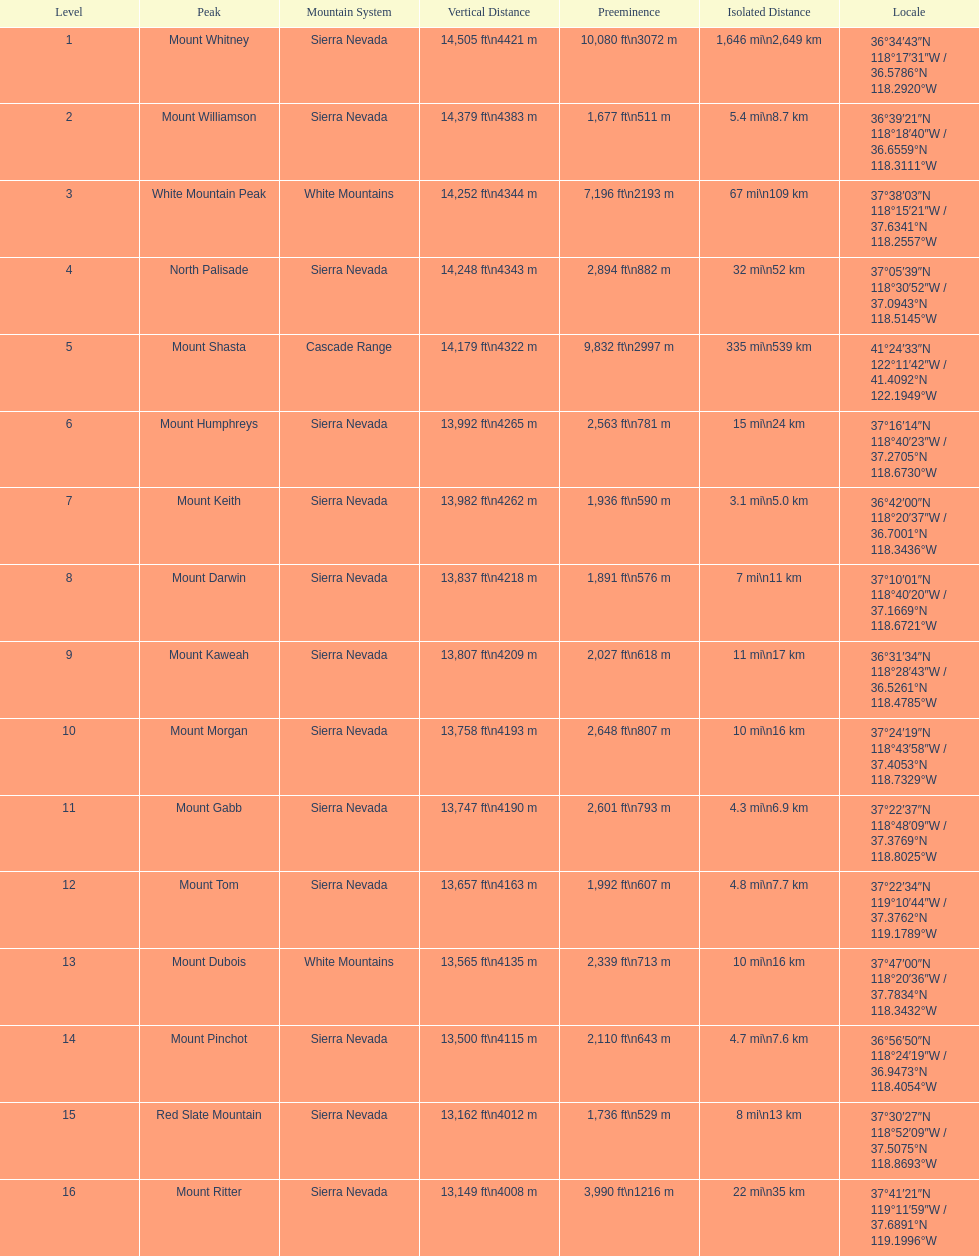How much taller is the mountain peak of mount williamson than that of mount keith? 397 ft. 